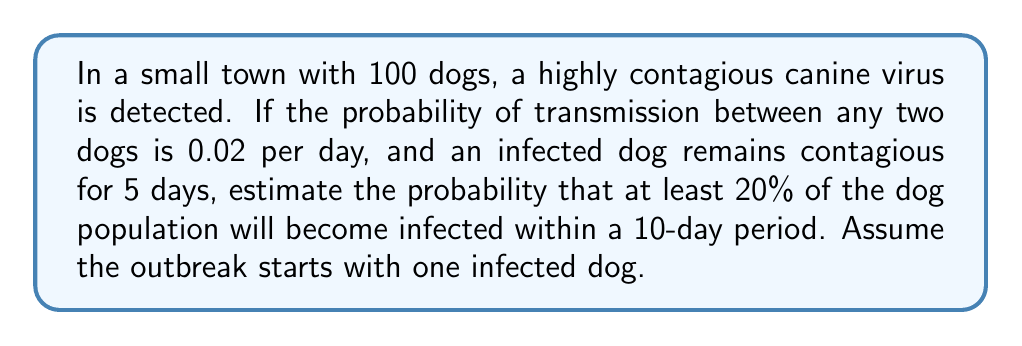What is the answer to this math problem? Let's approach this step-by-step using the SIR (Susceptible, Infected, Recovered) model:

1) First, we need to calculate the basic reproduction number $R_0$:
   $R_0 = \beta N \tau$
   where $\beta$ is the transmission rate, $N$ is the population size, and $\tau$ is the infectious period.

   $R_0 = 0.02 \times 100 \times 5 = 10$

2) The epidemic threshold is $1/R_0 = 1/10 = 0.1$. Since this is less than the initial fraction of susceptible animals (0.99), an outbreak is likely.

3) To estimate the final size of the epidemic, we can use the final size equation:
   $\ln(s_{\infty}) = R_0(s_{\infty} - 1)$
   where $s_{\infty}$ is the fraction of the population that remains susceptible.

4) Solving this numerically (e.g., using Newton's method), we get $s_{\infty} \approx 0.0067$.

5) This means the fraction infected is approximately $1 - 0.0067 = 0.9933$ or 99.33%.

6) To estimate the probability of reaching 20% infected within 10 days, we can use the exponential growth model:
   $I(t) = I_0 e^{rt}$
   where $I(t)$ is the number infected at time $t$, $I_0$ is the initial number infected, and $r$ is the growth rate.

7) The growth rate $r$ can be approximated as $r = (R_0 - 1)/\tau = (10 - 1)/5 = 1.8$

8) Solving for $t$ when $I(t) = 20$:
   $20 = 1 \times e^{1.8t}$
   $t = \ln(20)/1.8 \approx 1.67$ days

9) Since this is well within the 10-day period, and our final size calculation shows that the epidemic will likely infect nearly all dogs, the probability of reaching 20% infected within 10 days is very high, approaching 1.
Answer: $\approx 0.9999$ 